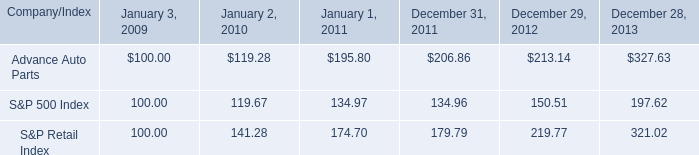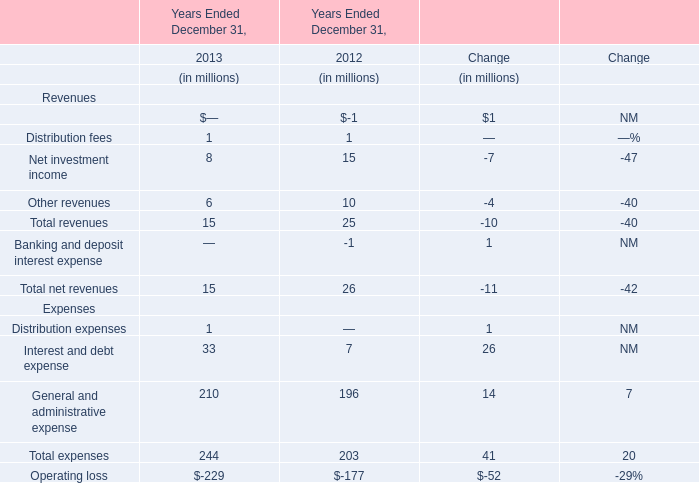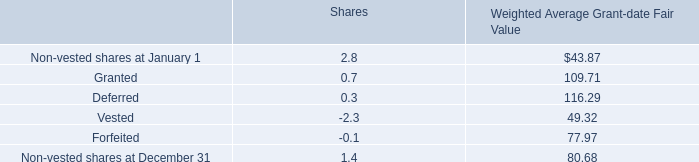What will General and administrative expense be like in 2014 if it continues to grow at the same rate as it did in 2013? (in million) 
Computations: (210 * (1 + ((210 - 196) / 196)))
Answer: 225.0. 